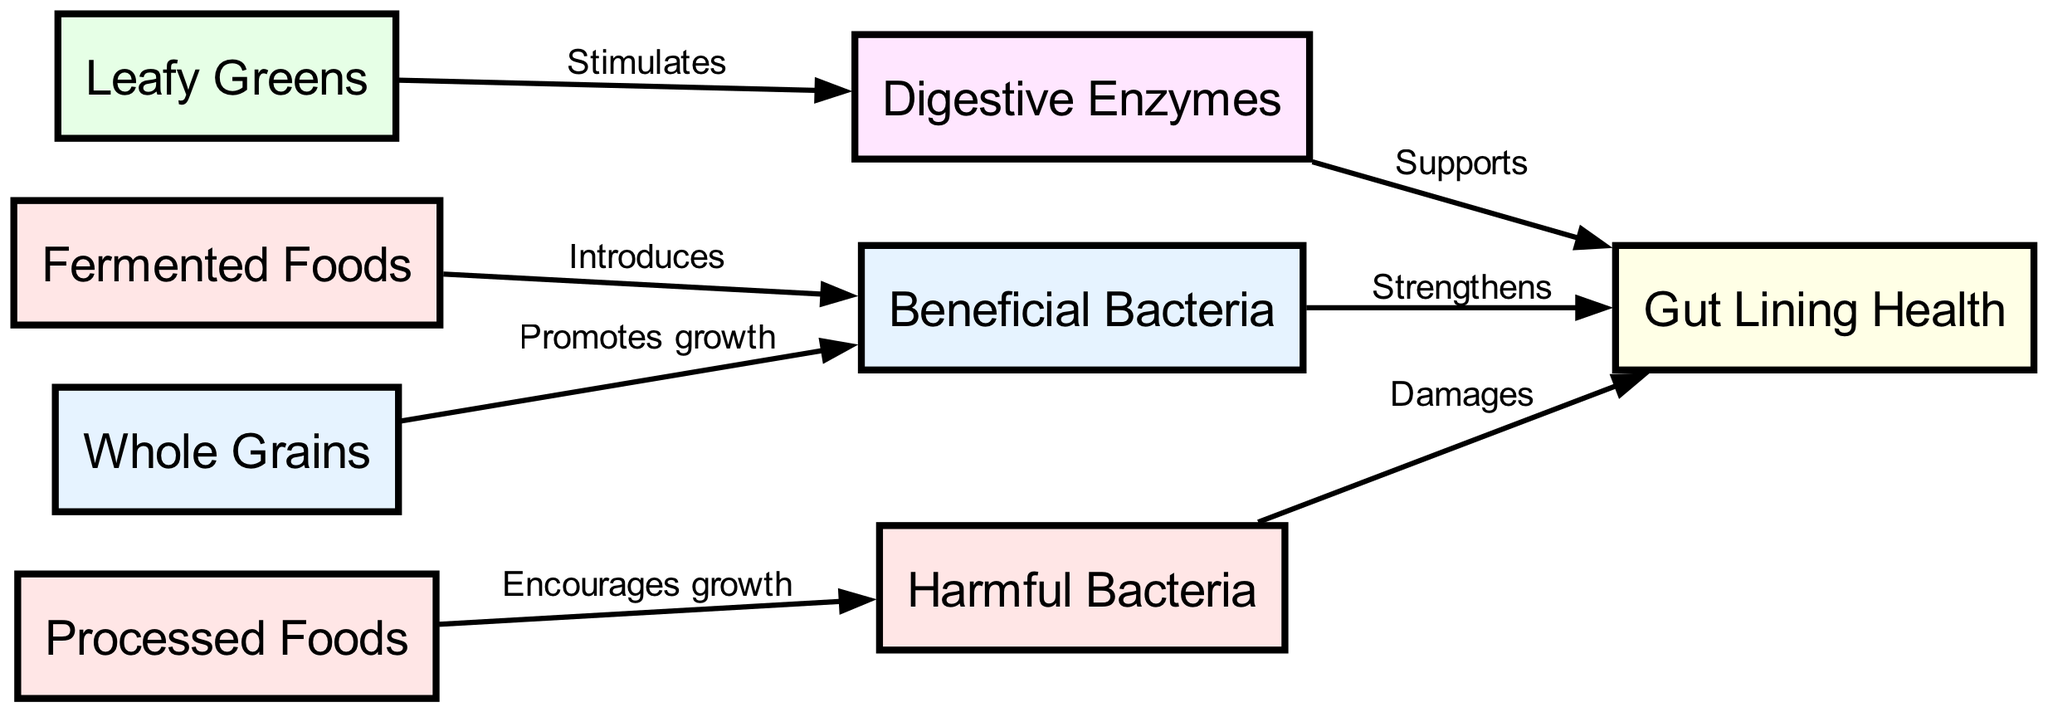What is the total number of nodes in the diagram? The diagram has eight nodes listed under the "nodes" section of the data provided. These nodes represent different components affecting gut microbiome health.
Answer: 8 How many edges are there in the diagram? There are seven edges connecting the nodes in the "edges" section of the data. These edges describe the relationships and interactions among the components.
Answer: 7 What does "Whole Grains" promote the growth of? According to the edge originating from "Whole Grains," it promotes the growth of "Beneficial Bacteria." This is derived directly from the relationship labeled on the connecting edge.
Answer: Beneficial Bacteria Which food type introduces beneficial bacteria into the gut? The edge from "Fermented Foods" to "Beneficial Bacteria" indicates that it introduces beneficial bacteria. This is a direct observation from the edge labeling in the diagram.
Answer: Fermented Foods What effect do "Processed Foods" have on gut health? The relationship indicates that "Processed Foods" encourage the growth of "Harmful Bacteria" in the gut. This connection is explicitly labeled in the diagram and shows the detrimental impact on gut health.
Answer: Encourages growth How do "Beneficial Bacteria" affect gut lining health? The edge from "Beneficial Bacteria" to "Gut Lining Health" demonstrates that they strengthen the gut lining. This connection highlights the importance of beneficial bacteria in maintaining gut integrity.
Answer: Strengthens What supports gut lining health apart from beneficial bacteria? "Digestive Enzymes" also support gut lining health, as indicated by the edge connecting them in the diagram. This shows that multiple elements contribute to maintaining the health of the gut lining.
Answer: Supports What is the direct impact of "Harmful Bacteria" on gut lining health? The diagram shows that "Harmful Bacteria" damage the gut lining health, which is demonstrated by the edge leading from "Harmful Bacteria" to "Gut Lining Health" labeled with "Damages."
Answer: Damages Which foods stimulate the production of digestive enzymes? "Leafy Greens" stimulate digestive enzymes, as indicated by the directed edge from "Leafy Greens" to "Digestive Enzymes." This relationship highlights the beneficial role of leafy greens in digestion.
Answer: Stimulates 